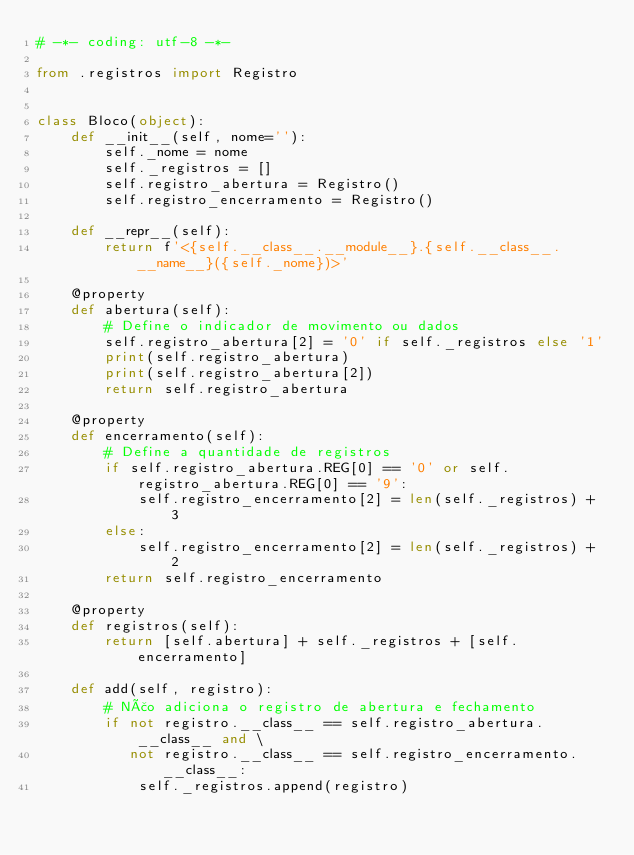<code> <loc_0><loc_0><loc_500><loc_500><_Python_># -*- coding: utf-8 -*-

from .registros import Registro


class Bloco(object):
    def __init__(self, nome=''):
        self._nome = nome
        self._registros = []
        self.registro_abertura = Registro()
        self.registro_encerramento = Registro()

    def __repr__(self):
        return f'<{self.__class__.__module__}.{self.__class__.__name__}({self._nome})>'

    @property
    def abertura(self):
        # Define o indicador de movimento ou dados
        self.registro_abertura[2] = '0' if self._registros else '1'
        print(self.registro_abertura)
        print(self.registro_abertura[2])
        return self.registro_abertura

    @property
    def encerramento(self):
        # Define a quantidade de registros
        if self.registro_abertura.REG[0] == '0' or self.registro_abertura.REG[0] == '9':
            self.registro_encerramento[2] = len(self._registros) + 3
        else:
            self.registro_encerramento[2] = len(self._registros) + 2
        return self.registro_encerramento

    @property
    def registros(self):
        return [self.abertura] + self._registros + [self.encerramento]

    def add(self, registro):
        # Não adiciona o registro de abertura e fechamento
        if not registro.__class__ == self.registro_abertura.__class__ and \
           not registro.__class__ == self.registro_encerramento.__class__:
            self._registros.append(registro)
</code> 